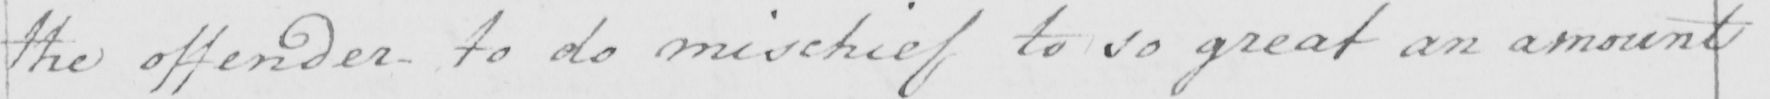Please provide the text content of this handwritten line. the offender to do mischief to so great an amount 